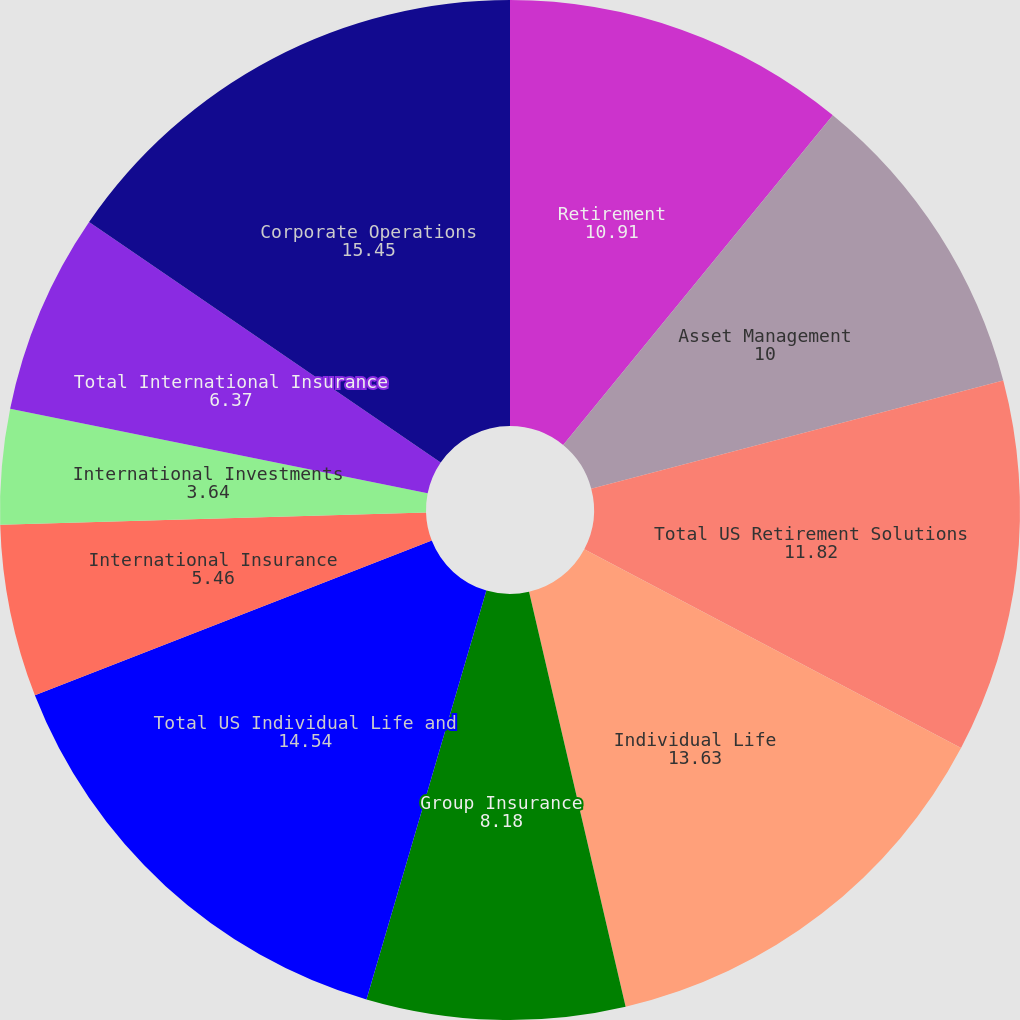Convert chart. <chart><loc_0><loc_0><loc_500><loc_500><pie_chart><fcel>Retirement<fcel>Asset Management<fcel>Total US Retirement Solutions<fcel>Individual Life<fcel>Group Insurance<fcel>Total US Individual Life and<fcel>International Insurance<fcel>International Investments<fcel>Total International Insurance<fcel>Corporate Operations<nl><fcel>10.91%<fcel>10.0%<fcel>11.82%<fcel>13.63%<fcel>8.18%<fcel>14.54%<fcel>5.46%<fcel>3.64%<fcel>6.37%<fcel>15.45%<nl></chart> 